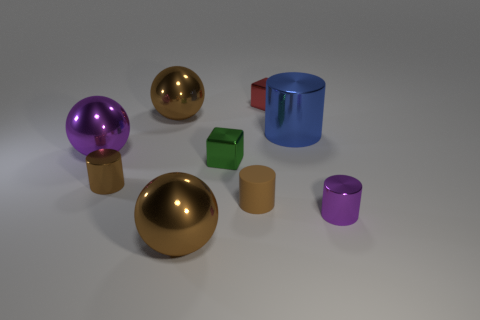Subtract all gray cylinders. Subtract all brown cubes. How many cylinders are left? 4 Add 1 brown cylinders. How many objects exist? 10 Subtract all cubes. How many objects are left? 7 Add 6 tiny red things. How many tiny red things are left? 7 Add 2 small red blocks. How many small red blocks exist? 3 Subtract 0 yellow cylinders. How many objects are left? 9 Subtract all gray rubber spheres. Subtract all large brown metal things. How many objects are left? 7 